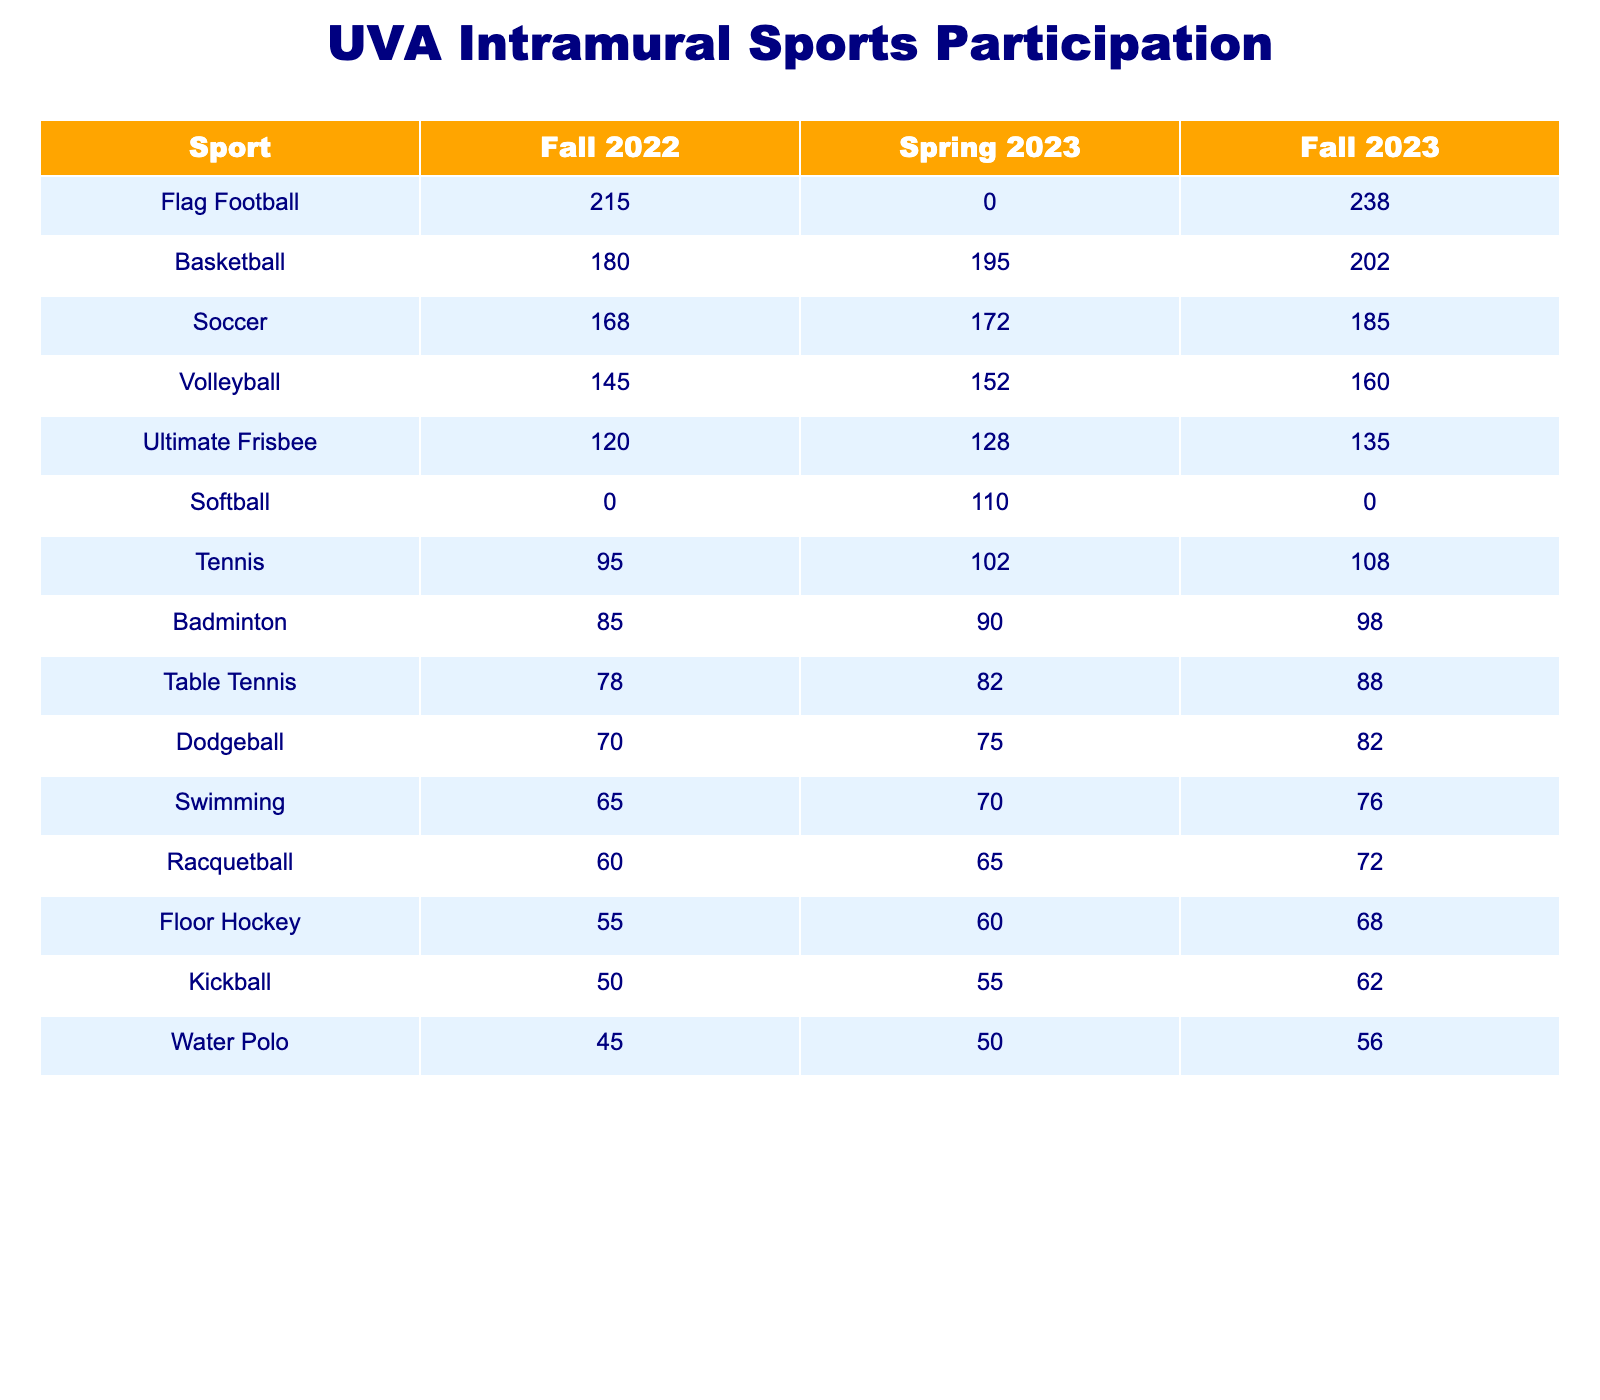What sport had the highest participation in Fall 2023? By looking at the Fall 2023 column, Flag Football shows 238 participants, which is higher than any other sport.
Answer: Flag Football How many total participants played Ultimate Frisbee across the three terms? Adding the participants from Fall 2022 (120), Spring 2023 (128), and Fall 2023 (135), the total is 120 + 128 + 135 = 383.
Answer: 383 Is there any sport for which the participation rate increased every term? By analyzing the participation rates for each sport, we see that Basketball increased from Fall 2022 (180) to Spring 2023 (195) and again to Fall 2023 (202), indicating a consistent increase.
Answer: Yes What were the total participation rates for Softball across the seasons? The participation for Softball was 0 in Fall 2022, 110 in Spring 2023, and 0 in Fall 2023. Adding these gives 0 + 110 + 0 = 110.
Answer: 110 Which sport had the least amount of participation in Spring 2023? Looking at the Spring 2023 values, Water Polo had the lowest participation with 50 participants, which is fewer than any other sport listed.
Answer: Water Polo What was the average participation for Tennis over the three terms? Calculating the average participation involves summing the participation rates: 95 (Fall 2022) + 102 (Spring 2023) + 108 (Fall 2023) = 305. Dividing by 3 gives 305 / 3 = 101.67, which rounds to 102.
Answer: 102 Did Racquetball have more participants in Fall 2023 compared to Fall 2022? For Fall 2022, Racquetball had 60 participants, whereas in Fall 2023 it increased to 72 participants, which confirms it had more in the later term.
Answer: Yes Which two sports had the closest participation numbers in Spring 2023? The participation numbers for Dodgeball (75) and Swimming (70) are the closest in Spring 2023 as the difference is just 5.
Answer: Dodgeball and Swimming What is the increase in participation for Floor Hockey from Fall 2022 to Fall 2023? Floor Hockey had 55 participants in Fall 2022 and increased to 68 in Fall 2023. The increase is 68 - 55 = 13 participants.
Answer: 13 Which sport maintained the same number of participants in the Fall 2023 term as it had in Spring 2023? Looking at the table, there's no sport with the same participant count from Spring 2023 to Fall 2023, confirming that none had maintained the same number in consecutive terms.
Answer: None 